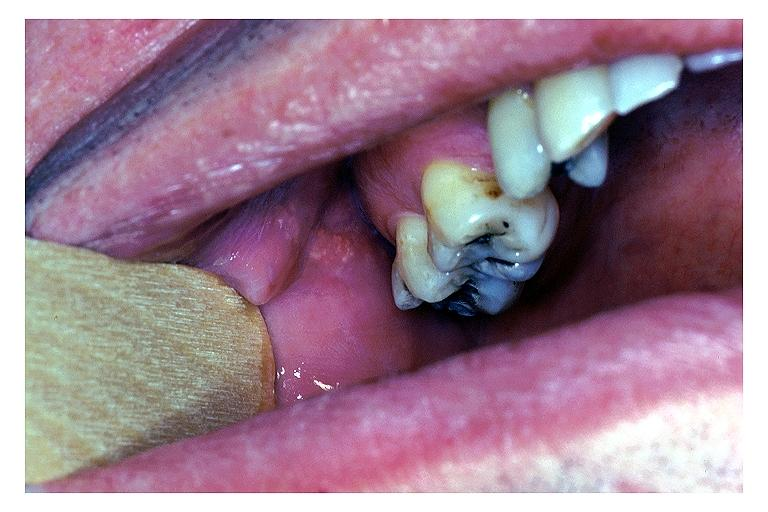s oral present?
Answer the question using a single word or phrase. Yes 